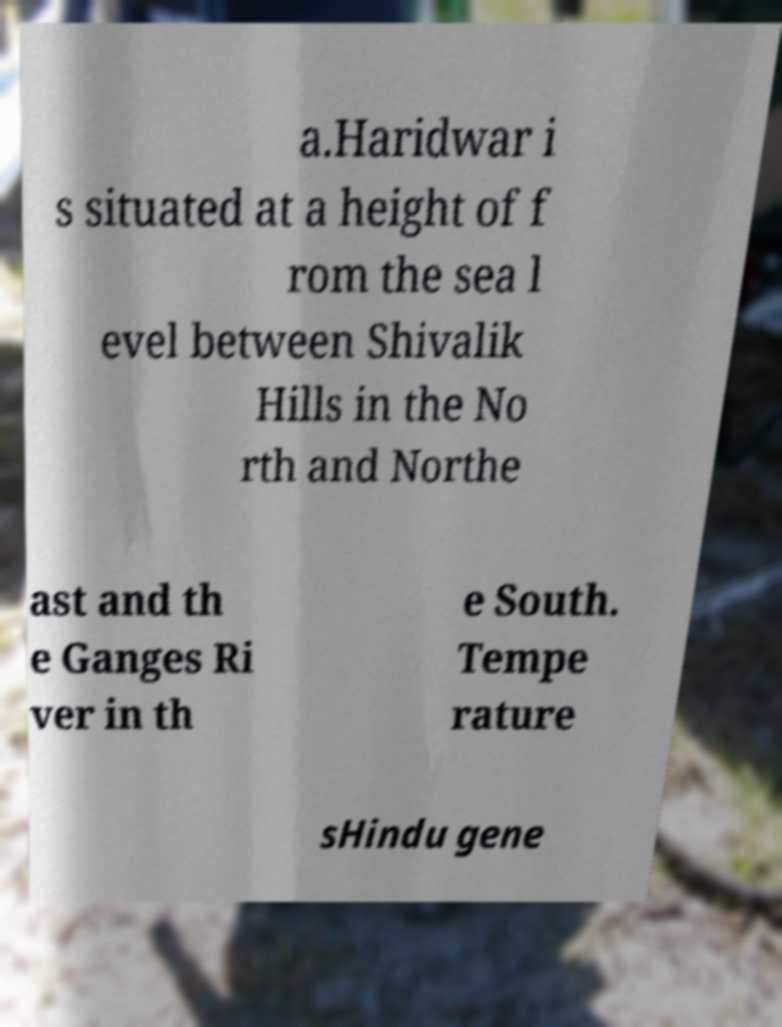Please identify and transcribe the text found in this image. a.Haridwar i s situated at a height of f rom the sea l evel between Shivalik Hills in the No rth and Northe ast and th e Ganges Ri ver in th e South. Tempe rature sHindu gene 